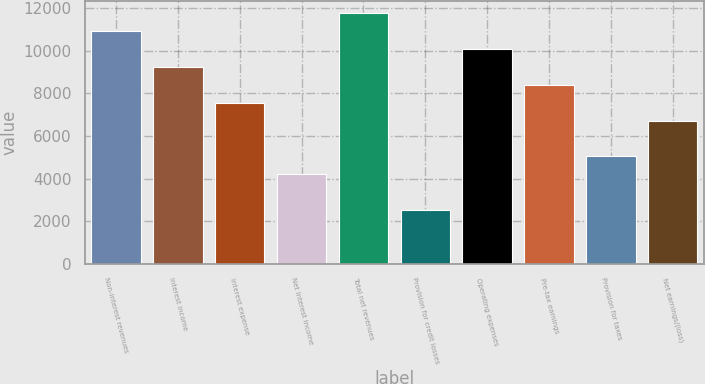Convert chart to OTSL. <chart><loc_0><loc_0><loc_500><loc_500><bar_chart><fcel>Non-interest revenues<fcel>Interest income<fcel>Interest expense<fcel>Net interest income<fcel>Total net revenues<fcel>Provision for credit losses<fcel>Operating expenses<fcel>Pre-tax earnings<fcel>Provision for taxes<fcel>Net earnings/(loss)<nl><fcel>10906.8<fcel>9228.93<fcel>7551.09<fcel>4195.39<fcel>11745.7<fcel>2517.53<fcel>10067.9<fcel>8390.01<fcel>5034.32<fcel>6712.16<nl></chart> 